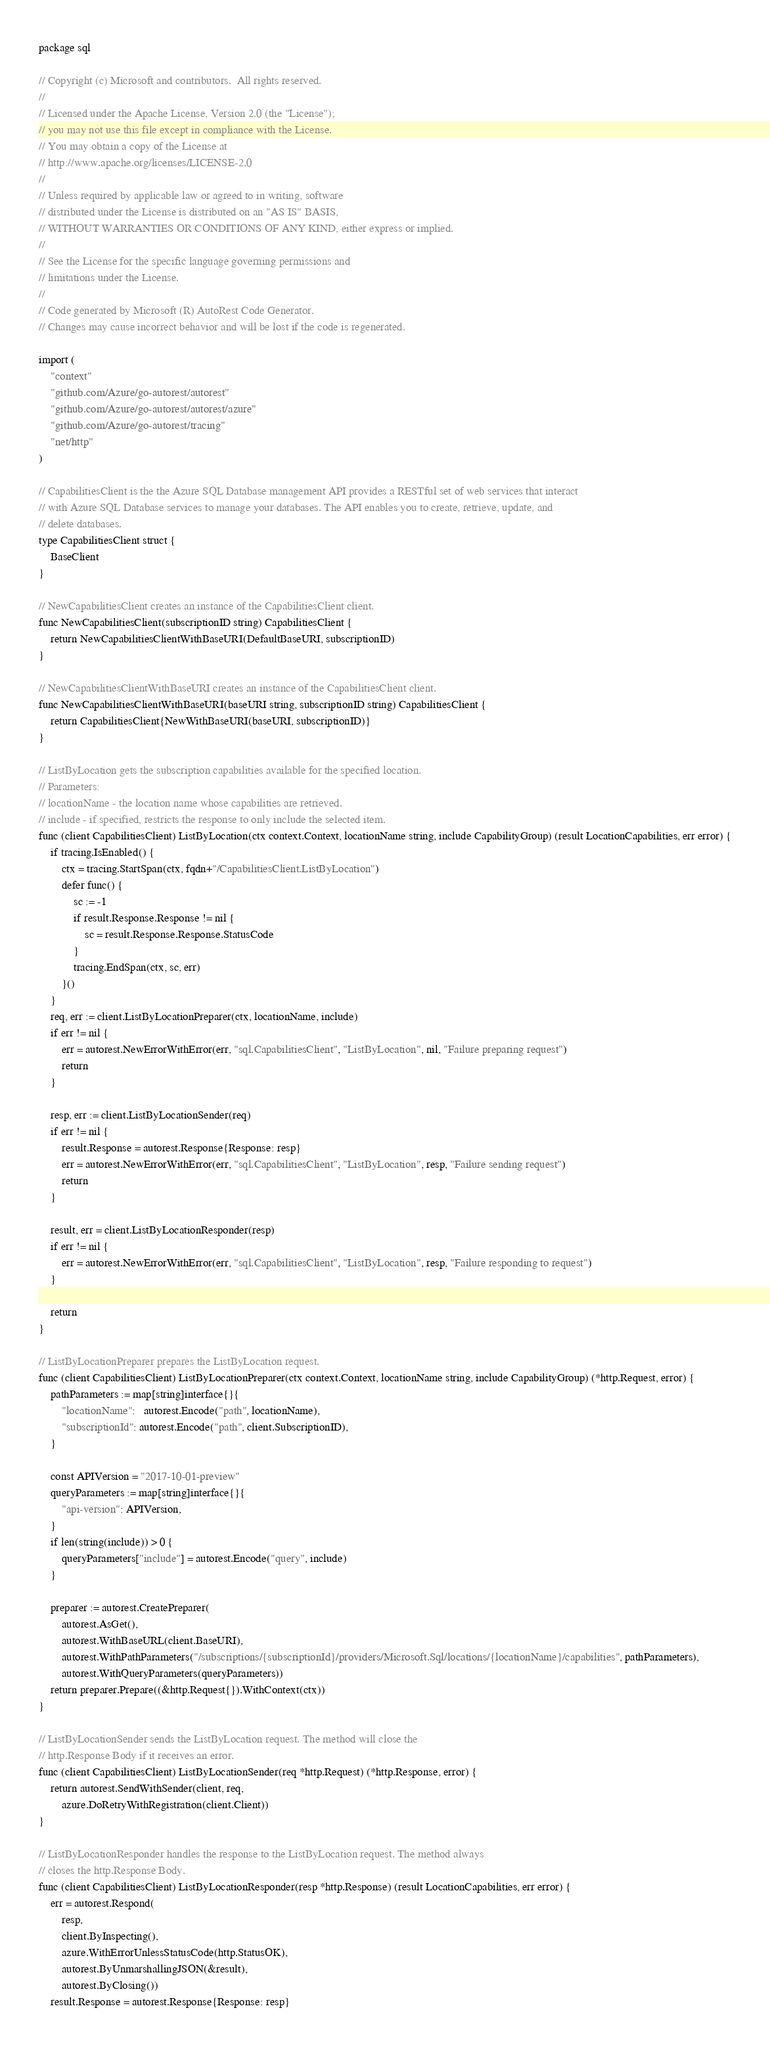<code> <loc_0><loc_0><loc_500><loc_500><_Go_>package sql

// Copyright (c) Microsoft and contributors.  All rights reserved.
//
// Licensed under the Apache License, Version 2.0 (the "License");
// you may not use this file except in compliance with the License.
// You may obtain a copy of the License at
// http://www.apache.org/licenses/LICENSE-2.0
//
// Unless required by applicable law or agreed to in writing, software
// distributed under the License is distributed on an "AS IS" BASIS,
// WITHOUT WARRANTIES OR CONDITIONS OF ANY KIND, either express or implied.
//
// See the License for the specific language governing permissions and
// limitations under the License.
//
// Code generated by Microsoft (R) AutoRest Code Generator.
// Changes may cause incorrect behavior and will be lost if the code is regenerated.

import (
	"context"
	"github.com/Azure/go-autorest/autorest"
	"github.com/Azure/go-autorest/autorest/azure"
	"github.com/Azure/go-autorest/tracing"
	"net/http"
)

// CapabilitiesClient is the the Azure SQL Database management API provides a RESTful set of web services that interact
// with Azure SQL Database services to manage your databases. The API enables you to create, retrieve, update, and
// delete databases.
type CapabilitiesClient struct {
	BaseClient
}

// NewCapabilitiesClient creates an instance of the CapabilitiesClient client.
func NewCapabilitiesClient(subscriptionID string) CapabilitiesClient {
	return NewCapabilitiesClientWithBaseURI(DefaultBaseURI, subscriptionID)
}

// NewCapabilitiesClientWithBaseURI creates an instance of the CapabilitiesClient client.
func NewCapabilitiesClientWithBaseURI(baseURI string, subscriptionID string) CapabilitiesClient {
	return CapabilitiesClient{NewWithBaseURI(baseURI, subscriptionID)}
}

// ListByLocation gets the subscription capabilities available for the specified location.
// Parameters:
// locationName - the location name whose capabilities are retrieved.
// include - if specified, restricts the response to only include the selected item.
func (client CapabilitiesClient) ListByLocation(ctx context.Context, locationName string, include CapabilityGroup) (result LocationCapabilities, err error) {
	if tracing.IsEnabled() {
		ctx = tracing.StartSpan(ctx, fqdn+"/CapabilitiesClient.ListByLocation")
		defer func() {
			sc := -1
			if result.Response.Response != nil {
				sc = result.Response.Response.StatusCode
			}
			tracing.EndSpan(ctx, sc, err)
		}()
	}
	req, err := client.ListByLocationPreparer(ctx, locationName, include)
	if err != nil {
		err = autorest.NewErrorWithError(err, "sql.CapabilitiesClient", "ListByLocation", nil, "Failure preparing request")
		return
	}

	resp, err := client.ListByLocationSender(req)
	if err != nil {
		result.Response = autorest.Response{Response: resp}
		err = autorest.NewErrorWithError(err, "sql.CapabilitiesClient", "ListByLocation", resp, "Failure sending request")
		return
	}

	result, err = client.ListByLocationResponder(resp)
	if err != nil {
		err = autorest.NewErrorWithError(err, "sql.CapabilitiesClient", "ListByLocation", resp, "Failure responding to request")
	}

	return
}

// ListByLocationPreparer prepares the ListByLocation request.
func (client CapabilitiesClient) ListByLocationPreparer(ctx context.Context, locationName string, include CapabilityGroup) (*http.Request, error) {
	pathParameters := map[string]interface{}{
		"locationName":   autorest.Encode("path", locationName),
		"subscriptionId": autorest.Encode("path", client.SubscriptionID),
	}

	const APIVersion = "2017-10-01-preview"
	queryParameters := map[string]interface{}{
		"api-version": APIVersion,
	}
	if len(string(include)) > 0 {
		queryParameters["include"] = autorest.Encode("query", include)
	}

	preparer := autorest.CreatePreparer(
		autorest.AsGet(),
		autorest.WithBaseURL(client.BaseURI),
		autorest.WithPathParameters("/subscriptions/{subscriptionId}/providers/Microsoft.Sql/locations/{locationName}/capabilities", pathParameters),
		autorest.WithQueryParameters(queryParameters))
	return preparer.Prepare((&http.Request{}).WithContext(ctx))
}

// ListByLocationSender sends the ListByLocation request. The method will close the
// http.Response Body if it receives an error.
func (client CapabilitiesClient) ListByLocationSender(req *http.Request) (*http.Response, error) {
	return autorest.SendWithSender(client, req,
		azure.DoRetryWithRegistration(client.Client))
}

// ListByLocationResponder handles the response to the ListByLocation request. The method always
// closes the http.Response Body.
func (client CapabilitiesClient) ListByLocationResponder(resp *http.Response) (result LocationCapabilities, err error) {
	err = autorest.Respond(
		resp,
		client.ByInspecting(),
		azure.WithErrorUnlessStatusCode(http.StatusOK),
		autorest.ByUnmarshallingJSON(&result),
		autorest.ByClosing())
	result.Response = autorest.Response{Response: resp}</code> 